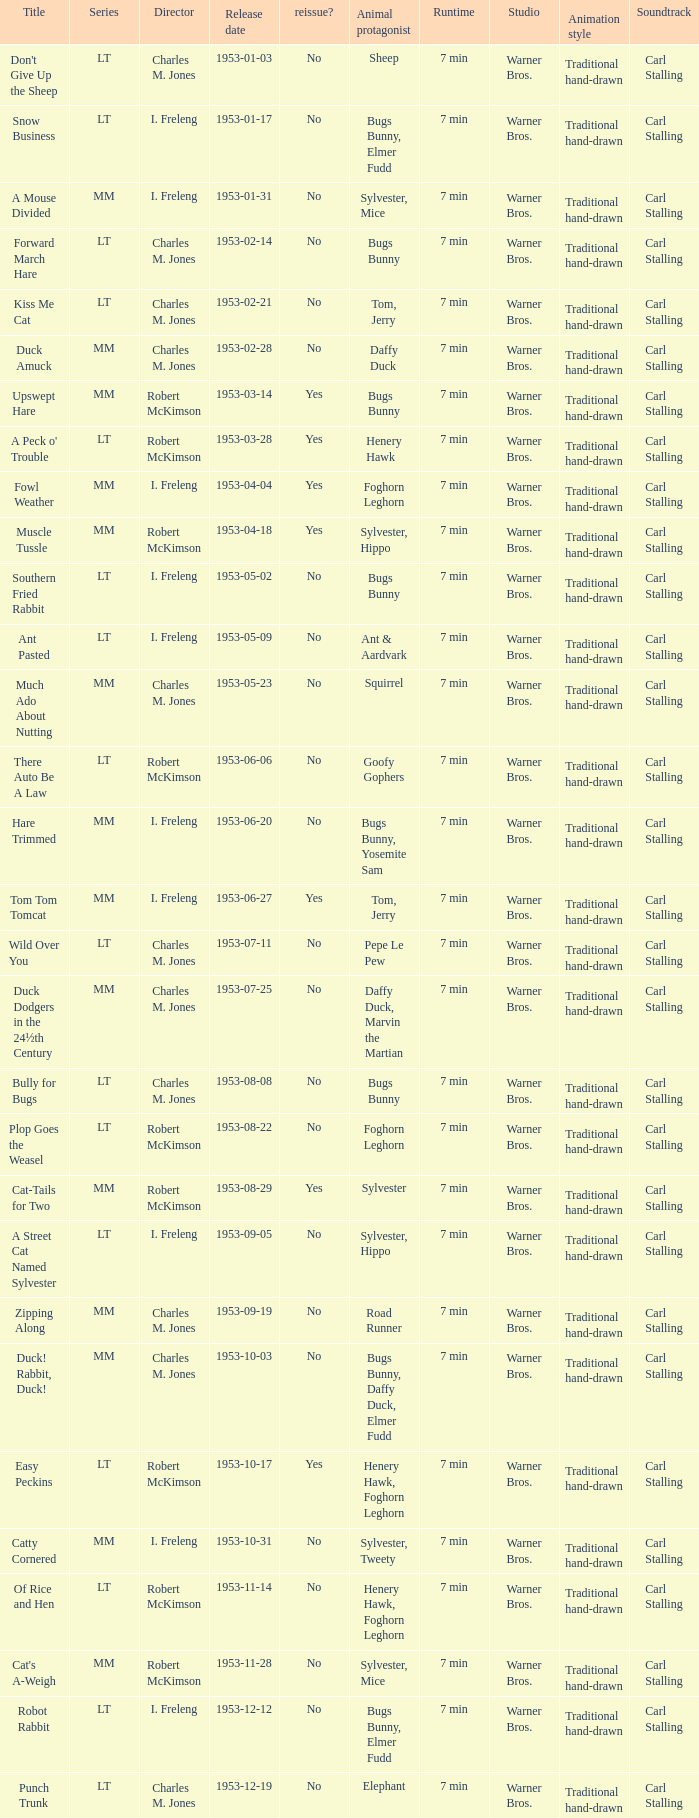Was there a reissue of the film released on 1953-10-03? No. 